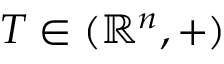<formula> <loc_0><loc_0><loc_500><loc_500>T \in ( \mathbb { R } ^ { n } , + )</formula> 